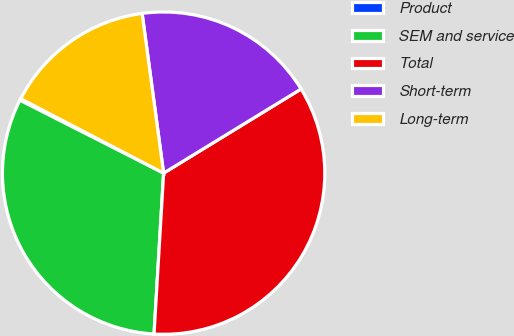<chart> <loc_0><loc_0><loc_500><loc_500><pie_chart><fcel>Product<fcel>SEM and service<fcel>Total<fcel>Short-term<fcel>Long-term<nl><fcel>0.17%<fcel>31.53%<fcel>34.69%<fcel>18.39%<fcel>15.23%<nl></chart> 